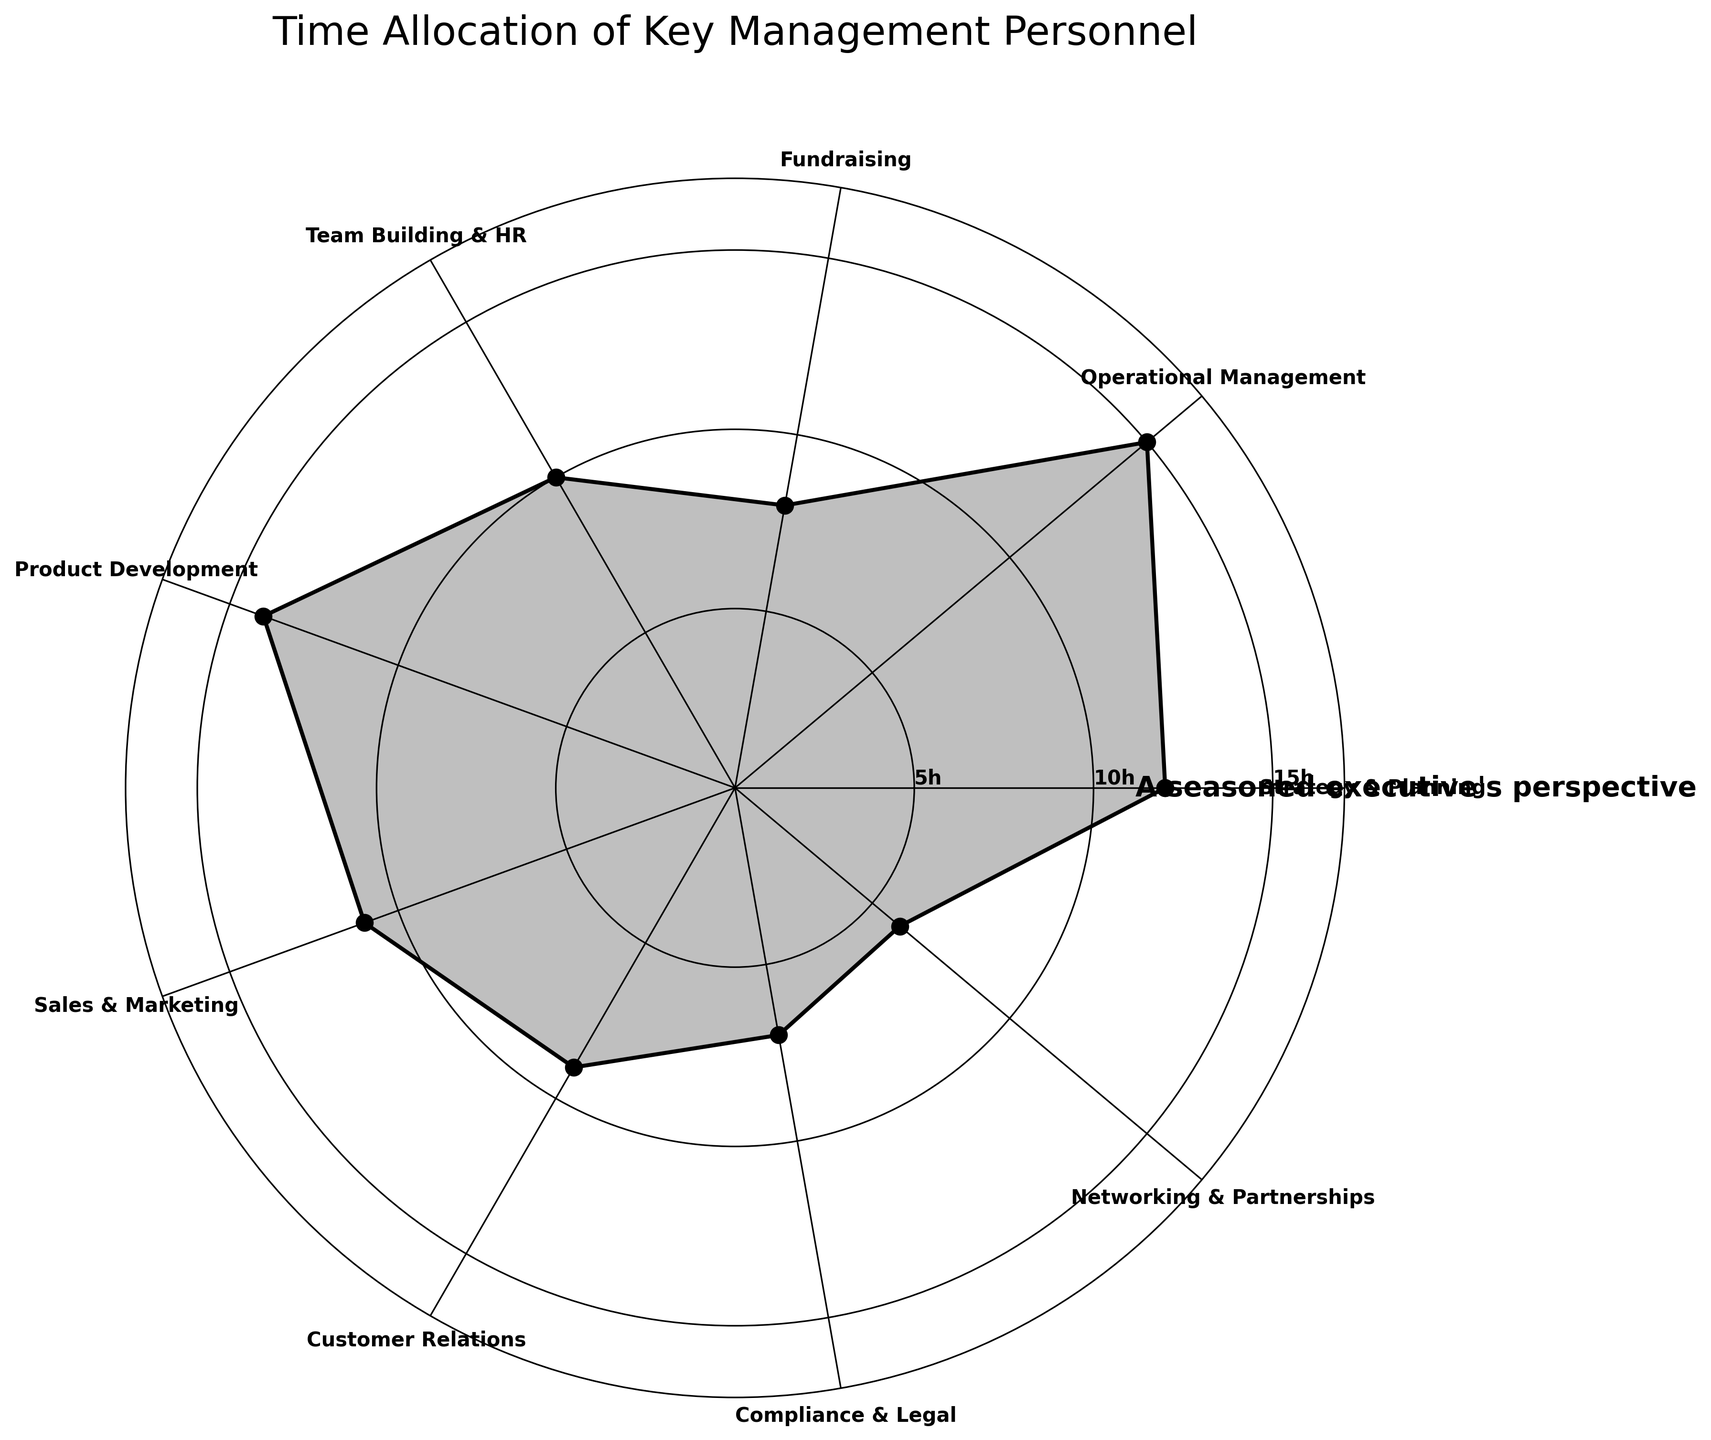What's the title of the figure? The title is located at the top of the figure. It reads "Time Allocation of Key Management Personnel."
Answer: Time Allocation of Key Management Personnel How many core activities are listed in the figure? To ascertain the number of core activities, count all the named activities placed along the circular edge of the rose chart.
Answer: 9 Which core activity is allocated the most hours? Identify the activity associated with the longest radial length in the polar plot. In this chart, the corresponding activity is positioned at 15 hours per week.
Answer: Operational Management What is the total number of hours allocated to fundraising, sales & marketing, and customer relations combined? Sum the hours spent on each specified activity (8 for Fundraising, 11 for Sales & Marketing, and 9 for Customer Relations.) Calculation: 8 + 11 + 9 = 28
Answer: 28 How much more time is dedicated to product development compared to compliance & legal? Find the hours for both activities and then calculate the difference. Hours for Product Development are 14 and for Compliance & Legal are 7. The difference is 14 - 7 = 7 hours.
Answer: 7 hours What is the average number of hours spent on the listed activities? Calculate the total sum of hours across all activities and divide by the number of activities. Total hours = 12 + 15 + 8 + 10 + 14 + 11 + 9 + 7 + 6 = 92. Number of activities = 9. Average = 92 / 9 ≈ 10.22
Answer: 10.22 hours Which activity has the smallest allocation of time, and how many hours are allocated to it? Determine the shortest radial length in the polar plot, which represents the activity with the fewest hours.
Answer: Networking & Partnerships, 6 hours How does the time allocation for customer relations compare to team building & HR? Compare the hours allocated to both activities. Customer Relations is 9 hours, while Team Building & HR is 10 hours. Customer Relations has 1 hour less.
Answer: 1 hour less What is the combined time spent on strategy & planning and operational management? Sum the hours for both activities (12 for Strategy & Planning and 15 for Operational Management). Calculation: 12 + 15 = 27 hours.
Answer: 27 hours What's the median number of hours spent on these core activities? Arrange the number of hours in ascending order (6, 7, 8, 9, 10, 11, 12, 14, 15) and find the middle value. The median is the 5th value in this sorted list.
Answer: 10 hours 